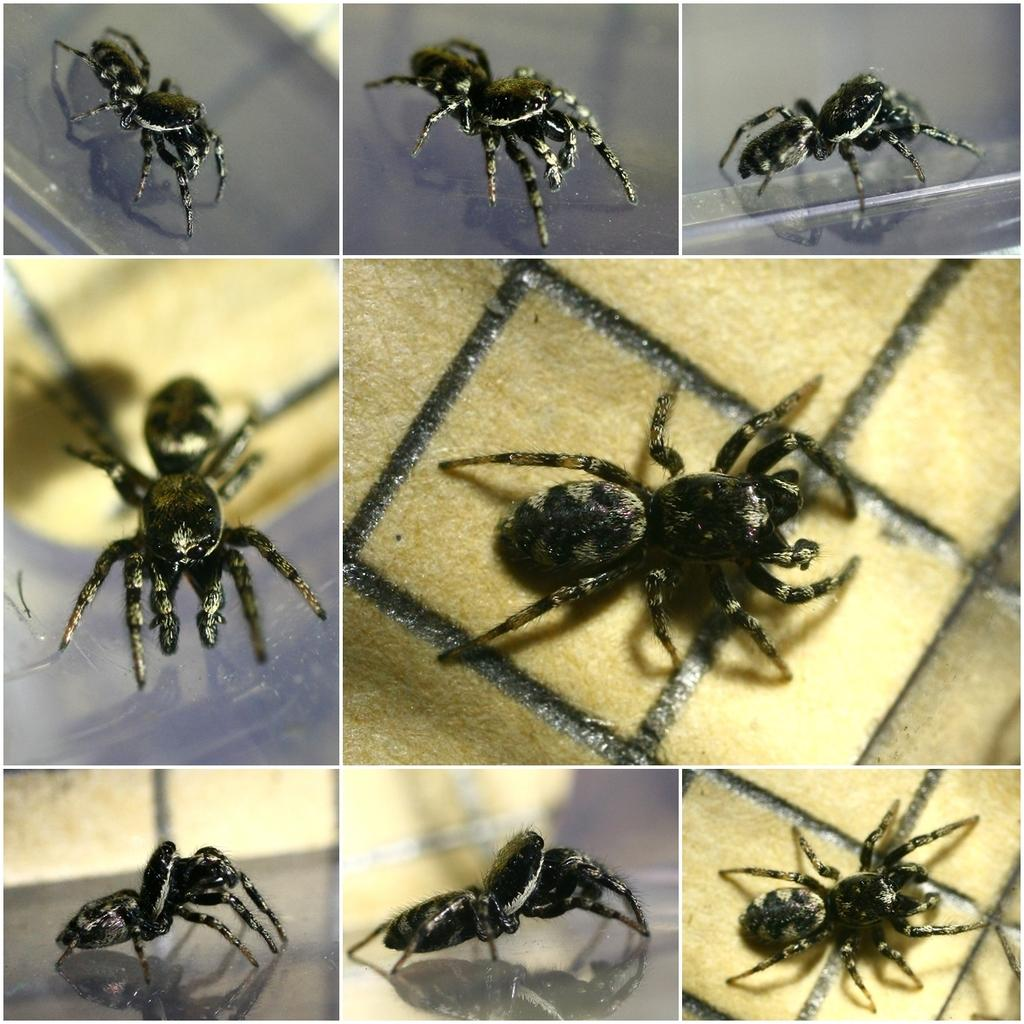What is the main subject of the image? The main subject of the image is a collage of an insect. Can you describe the insect in the collage? Unfortunately, the image only shows a collage of the insect, so specific details about the insect cannot be determined. What type of property does the insect own in the image? There is no indication in the image that the insect owns any property. 